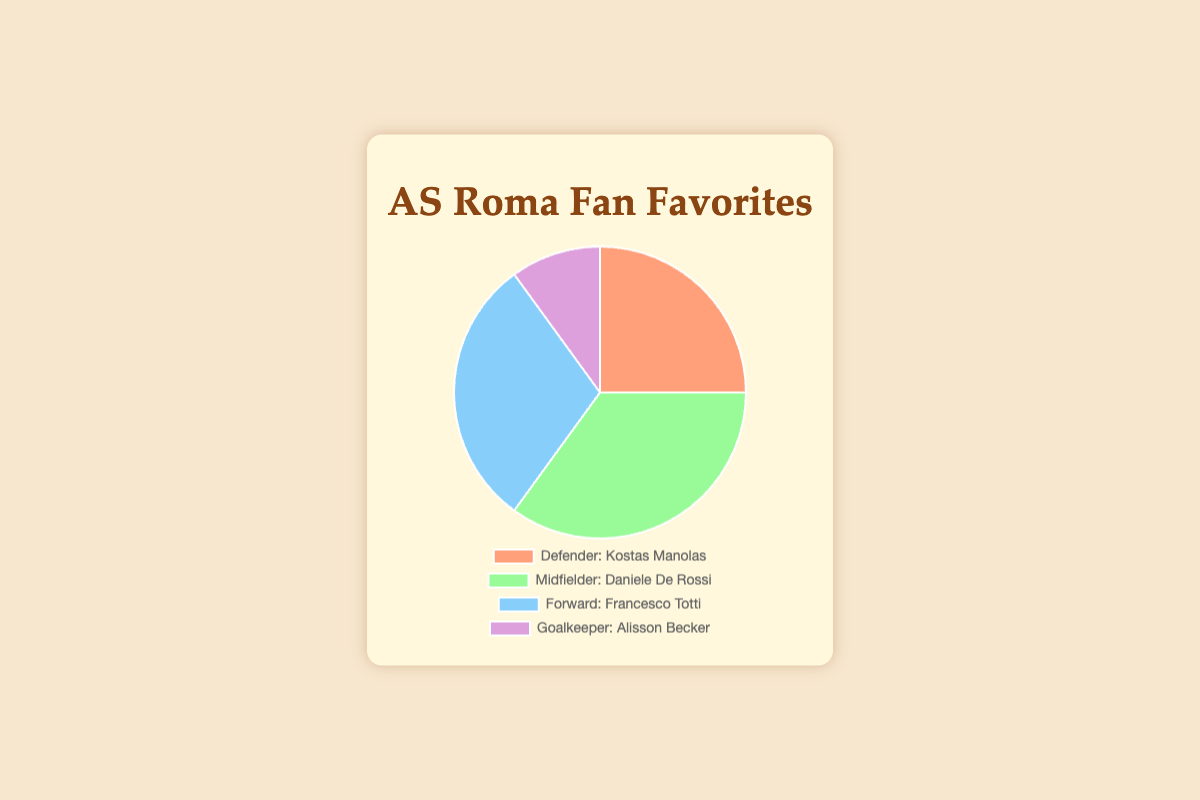What's the percentage of AS Roma fans who favor Francesco Totti as compared to Alisson Becker? To find the percentage difference, we subtract the percentage of fans who favor Alisson Becker (10%) from those who favor Francesco Totti (30%). Therefore, the percentage difference is 30% - 10% = 20%.
Answer: 20% Which position has the least favorite player according to AS Roma fans? By examining the pie chart, the position with the lowest percentage is Goalkeeper, represented by Alisson Becker at 10%.
Answer: Goalkeeper What is the combined percentage of fans who favor players in the Midfielder and Defender positions? The Midfielder position is favored by 35% of fans, and the Defender position by 25%. Summing these percentages gives 35% + 25% = 60%.
Answer: 60% How much more popular is Daniele De Rossi compared to Kostas Manolas? Daniele De Rossi has 35% of the fan vote while Kostas Manolas has 25%. The difference in popularity is 35% - 25% = 10%.
Answer: 10% What proportion of the pie chart does Francesco Totti represent? Francesco Totti is favored by 30% of fans. Thus, he represents 30% of the pie chart.
Answer: 30% Which two positions together account for half of the total fan preferences? By adding the percentages, Forward (30%) and Defender (25%) sum up to 30% + 25% = 55%, and Forward (30%) and Goalkeeper (10%) sum up to 40%. The correct pair that sums to 50% is Defender (25%) and Midfielder (35%) which add to 25% + 35% = 60%. No pair sums to exactly 50%, but 55% is closest.
Answer: Forward and Defender If you were to combine the popularity of the Defender and Forward positions, would they surpass the Midfielder position? The combined percentage for Defender (25%) and Forward (30%) is 25% + 30% = 55%, which is greater than the Midfielder position at 35%.
Answer: Yes 